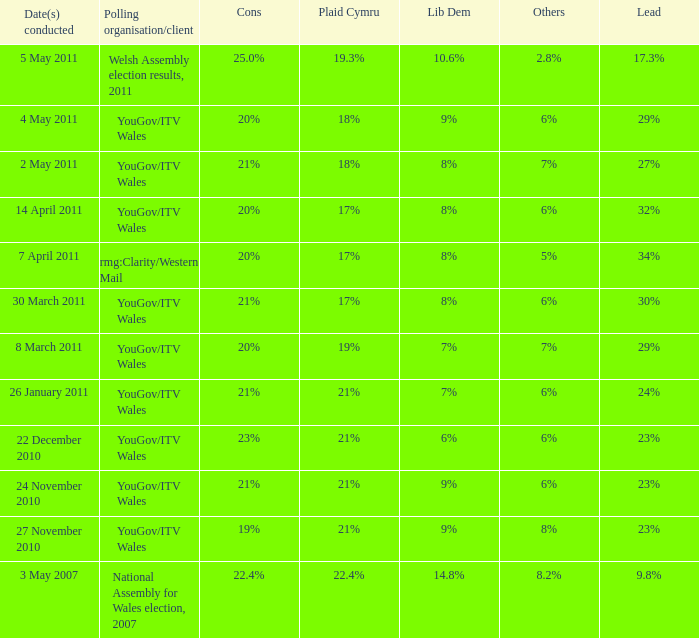What are the negative aspects for lib dem having an 8% backing and a 27% advantage? 21%. 